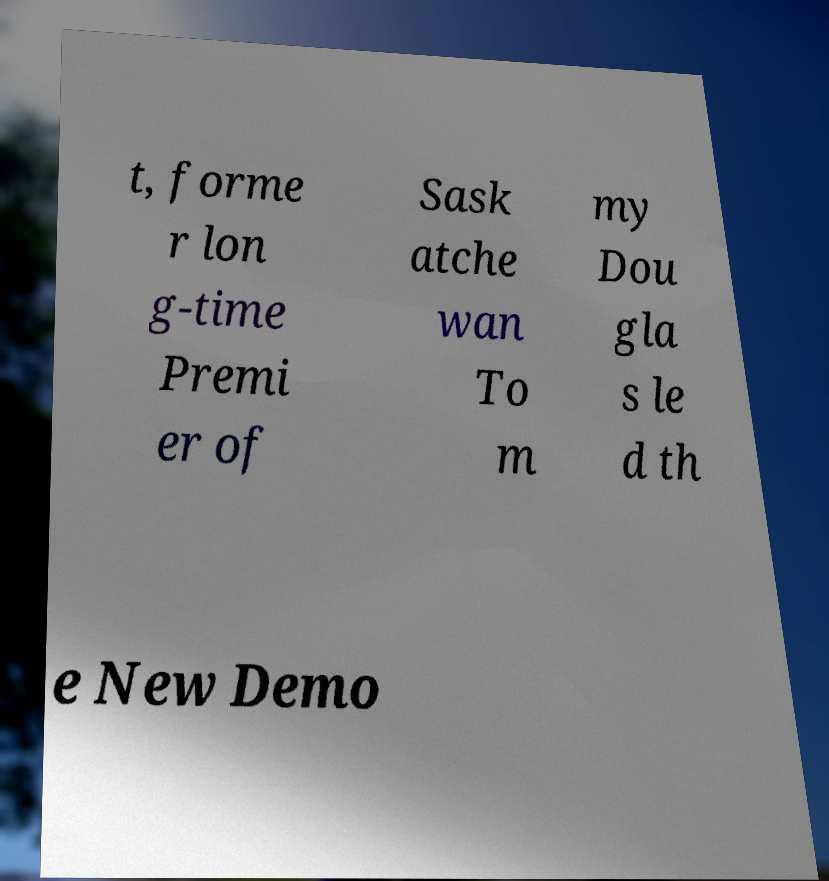I need the written content from this picture converted into text. Can you do that? t, forme r lon g-time Premi er of Sask atche wan To m my Dou gla s le d th e New Demo 